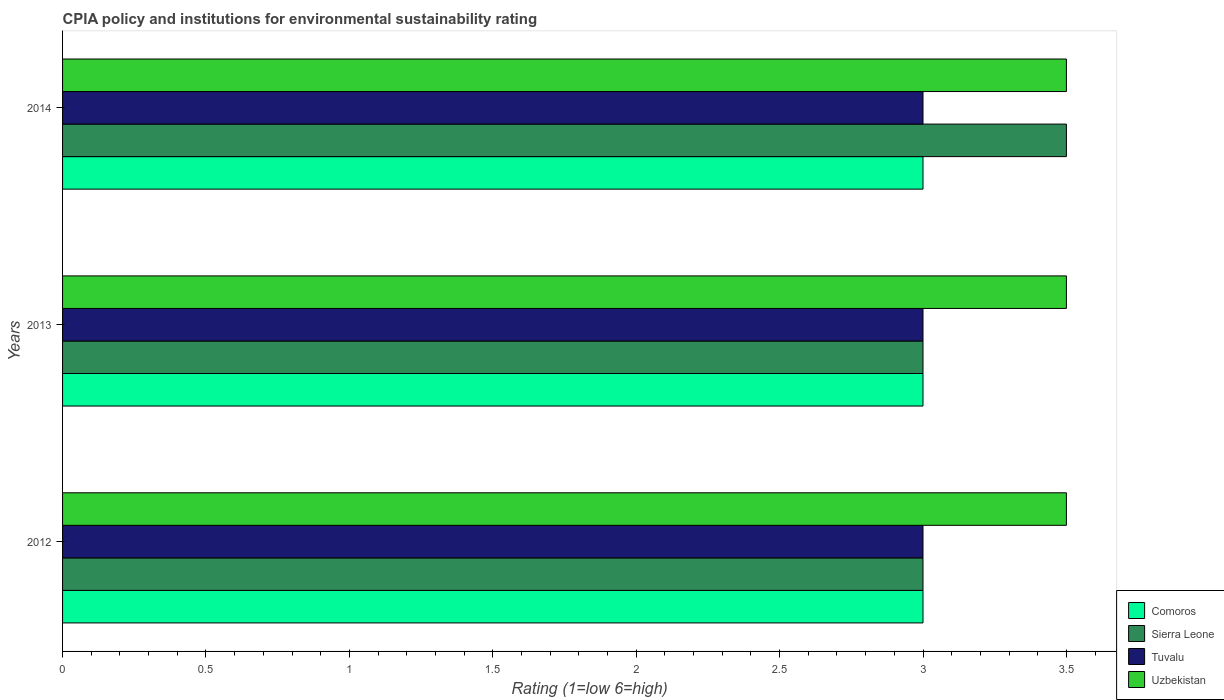How many different coloured bars are there?
Keep it short and to the point. 4. How many groups of bars are there?
Ensure brevity in your answer.  3. In how many cases, is the number of bars for a given year not equal to the number of legend labels?
Your answer should be compact. 0. What is the CPIA rating in Tuvalu in 2013?
Make the answer very short. 3. Across all years, what is the maximum CPIA rating in Tuvalu?
Provide a short and direct response. 3. What is the difference between the CPIA rating in Sierra Leone in 2014 and the CPIA rating in Tuvalu in 2012?
Your answer should be very brief. 0.5. In the year 2012, what is the difference between the CPIA rating in Sierra Leone and CPIA rating in Tuvalu?
Your answer should be compact. 0. In how many years, is the CPIA rating in Tuvalu greater than 2.5 ?
Keep it short and to the point. 3. What is the ratio of the CPIA rating in Uzbekistan in 2012 to that in 2013?
Provide a succinct answer. 1. Is the CPIA rating in Sierra Leone in 2012 less than that in 2014?
Ensure brevity in your answer.  Yes. What is the difference between the highest and the lowest CPIA rating in Comoros?
Provide a short and direct response. 0. What does the 1st bar from the top in 2014 represents?
Provide a short and direct response. Uzbekistan. What does the 4th bar from the bottom in 2013 represents?
Your answer should be very brief. Uzbekistan. Is it the case that in every year, the sum of the CPIA rating in Tuvalu and CPIA rating in Sierra Leone is greater than the CPIA rating in Comoros?
Provide a short and direct response. Yes. Are all the bars in the graph horizontal?
Offer a terse response. Yes. Does the graph contain any zero values?
Give a very brief answer. No. What is the title of the graph?
Provide a short and direct response. CPIA policy and institutions for environmental sustainability rating. What is the Rating (1=low 6=high) of Comoros in 2012?
Your answer should be compact. 3. What is the Rating (1=low 6=high) in Tuvalu in 2012?
Give a very brief answer. 3. What is the Rating (1=low 6=high) in Comoros in 2013?
Make the answer very short. 3. What is the Rating (1=low 6=high) of Comoros in 2014?
Keep it short and to the point. 3. What is the Rating (1=low 6=high) in Sierra Leone in 2014?
Give a very brief answer. 3.5. What is the Rating (1=low 6=high) in Uzbekistan in 2014?
Ensure brevity in your answer.  3.5. Across all years, what is the minimum Rating (1=low 6=high) of Sierra Leone?
Your answer should be compact. 3. Across all years, what is the minimum Rating (1=low 6=high) in Tuvalu?
Make the answer very short. 3. Across all years, what is the minimum Rating (1=low 6=high) of Uzbekistan?
Provide a succinct answer. 3.5. What is the total Rating (1=low 6=high) in Comoros in the graph?
Offer a very short reply. 9. What is the total Rating (1=low 6=high) of Tuvalu in the graph?
Your answer should be very brief. 9. What is the difference between the Rating (1=low 6=high) of Sierra Leone in 2012 and that in 2013?
Your response must be concise. 0. What is the difference between the Rating (1=low 6=high) of Comoros in 2012 and that in 2014?
Keep it short and to the point. 0. What is the difference between the Rating (1=low 6=high) of Tuvalu in 2012 and that in 2014?
Provide a succinct answer. 0. What is the difference between the Rating (1=low 6=high) in Sierra Leone in 2013 and that in 2014?
Ensure brevity in your answer.  -0.5. What is the difference between the Rating (1=low 6=high) of Tuvalu in 2013 and that in 2014?
Give a very brief answer. 0. What is the difference between the Rating (1=low 6=high) of Comoros in 2012 and the Rating (1=low 6=high) of Tuvalu in 2013?
Offer a terse response. 0. What is the difference between the Rating (1=low 6=high) in Sierra Leone in 2012 and the Rating (1=low 6=high) in Tuvalu in 2013?
Your answer should be very brief. 0. What is the difference between the Rating (1=low 6=high) in Tuvalu in 2012 and the Rating (1=low 6=high) in Uzbekistan in 2013?
Your response must be concise. -0.5. What is the difference between the Rating (1=low 6=high) in Comoros in 2012 and the Rating (1=low 6=high) in Sierra Leone in 2014?
Keep it short and to the point. -0.5. What is the difference between the Rating (1=low 6=high) of Comoros in 2012 and the Rating (1=low 6=high) of Tuvalu in 2014?
Provide a succinct answer. 0. What is the difference between the Rating (1=low 6=high) of Comoros in 2012 and the Rating (1=low 6=high) of Uzbekistan in 2014?
Your answer should be very brief. -0.5. What is the difference between the Rating (1=low 6=high) of Sierra Leone in 2012 and the Rating (1=low 6=high) of Tuvalu in 2014?
Keep it short and to the point. 0. What is the difference between the Rating (1=low 6=high) in Tuvalu in 2012 and the Rating (1=low 6=high) in Uzbekistan in 2014?
Provide a short and direct response. -0.5. What is the difference between the Rating (1=low 6=high) in Comoros in 2013 and the Rating (1=low 6=high) in Sierra Leone in 2014?
Your response must be concise. -0.5. What is the difference between the Rating (1=low 6=high) of Tuvalu in 2013 and the Rating (1=low 6=high) of Uzbekistan in 2014?
Ensure brevity in your answer.  -0.5. What is the average Rating (1=low 6=high) of Sierra Leone per year?
Ensure brevity in your answer.  3.17. What is the average Rating (1=low 6=high) in Uzbekistan per year?
Offer a very short reply. 3.5. In the year 2012, what is the difference between the Rating (1=low 6=high) of Comoros and Rating (1=low 6=high) of Uzbekistan?
Your response must be concise. -0.5. In the year 2012, what is the difference between the Rating (1=low 6=high) of Tuvalu and Rating (1=low 6=high) of Uzbekistan?
Your answer should be compact. -0.5. In the year 2013, what is the difference between the Rating (1=low 6=high) of Comoros and Rating (1=low 6=high) of Sierra Leone?
Ensure brevity in your answer.  0. In the year 2013, what is the difference between the Rating (1=low 6=high) of Comoros and Rating (1=low 6=high) of Tuvalu?
Offer a very short reply. 0. In the year 2013, what is the difference between the Rating (1=low 6=high) in Sierra Leone and Rating (1=low 6=high) in Tuvalu?
Offer a very short reply. 0. In the year 2013, what is the difference between the Rating (1=low 6=high) of Tuvalu and Rating (1=low 6=high) of Uzbekistan?
Your response must be concise. -0.5. In the year 2014, what is the difference between the Rating (1=low 6=high) of Comoros and Rating (1=low 6=high) of Uzbekistan?
Make the answer very short. -0.5. What is the ratio of the Rating (1=low 6=high) in Comoros in 2012 to that in 2013?
Your answer should be very brief. 1. What is the ratio of the Rating (1=low 6=high) of Comoros in 2012 to that in 2014?
Offer a terse response. 1. What is the ratio of the Rating (1=low 6=high) in Sierra Leone in 2012 to that in 2014?
Make the answer very short. 0.86. What is the ratio of the Rating (1=low 6=high) in Tuvalu in 2012 to that in 2014?
Your answer should be very brief. 1. What is the ratio of the Rating (1=low 6=high) in Uzbekistan in 2012 to that in 2014?
Offer a terse response. 1. What is the ratio of the Rating (1=low 6=high) of Tuvalu in 2013 to that in 2014?
Ensure brevity in your answer.  1. What is the ratio of the Rating (1=low 6=high) of Uzbekistan in 2013 to that in 2014?
Give a very brief answer. 1. 